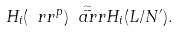<formula> <loc_0><loc_0><loc_500><loc_500>H _ { i } ( \ r r ^ { p } ) \overset { \simeq } { \ a r r } H _ { i } ( L / N ^ { \prime } ) .</formula> 